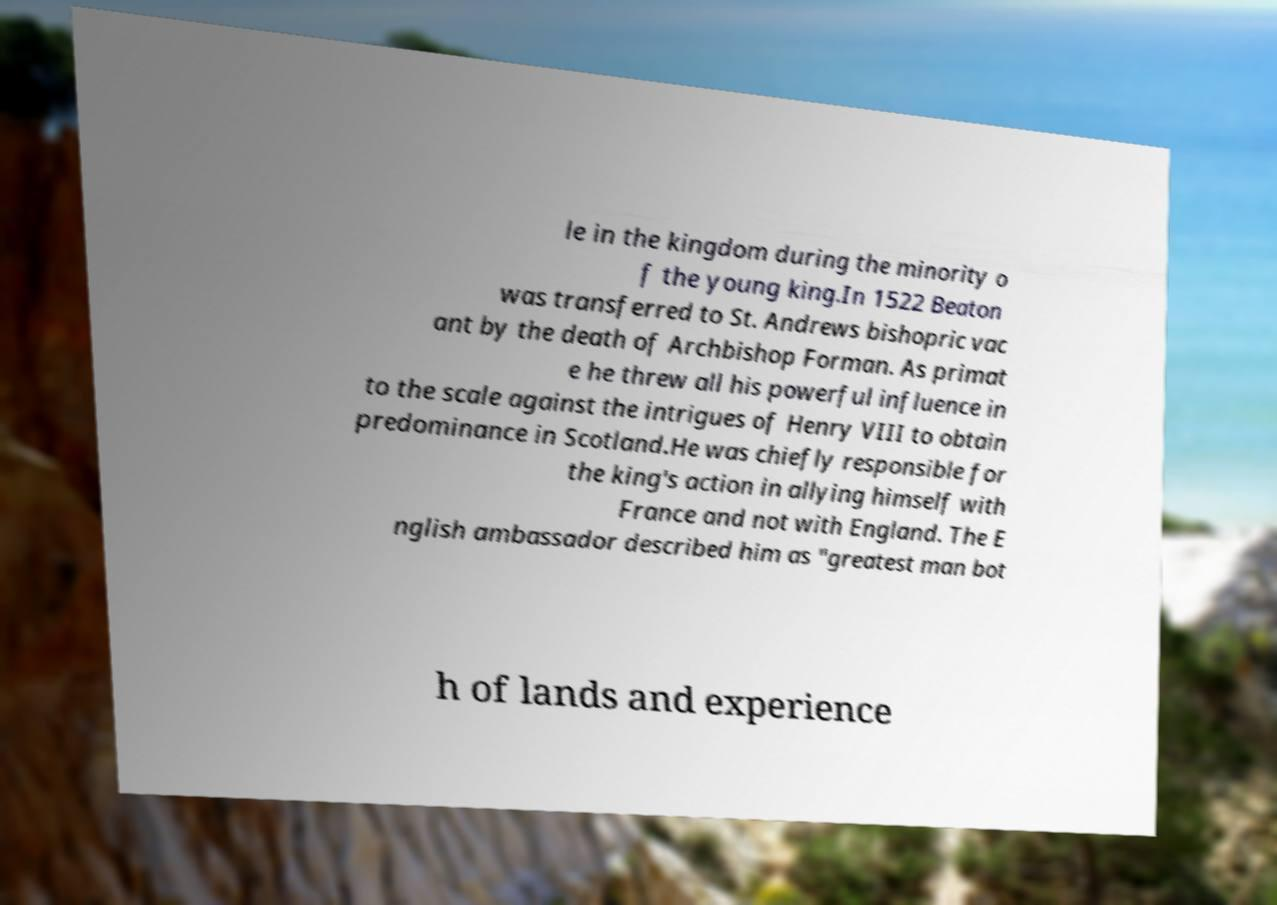Can you read and provide the text displayed in the image?This photo seems to have some interesting text. Can you extract and type it out for me? le in the kingdom during the minority o f the young king.In 1522 Beaton was transferred to St. Andrews bishopric vac ant by the death of Archbishop Forman. As primat e he threw all his powerful influence in to the scale against the intrigues of Henry VIII to obtain predominance in Scotland.He was chiefly responsible for the king's action in allying himself with France and not with England. The E nglish ambassador described him as "greatest man bot h of lands and experience 